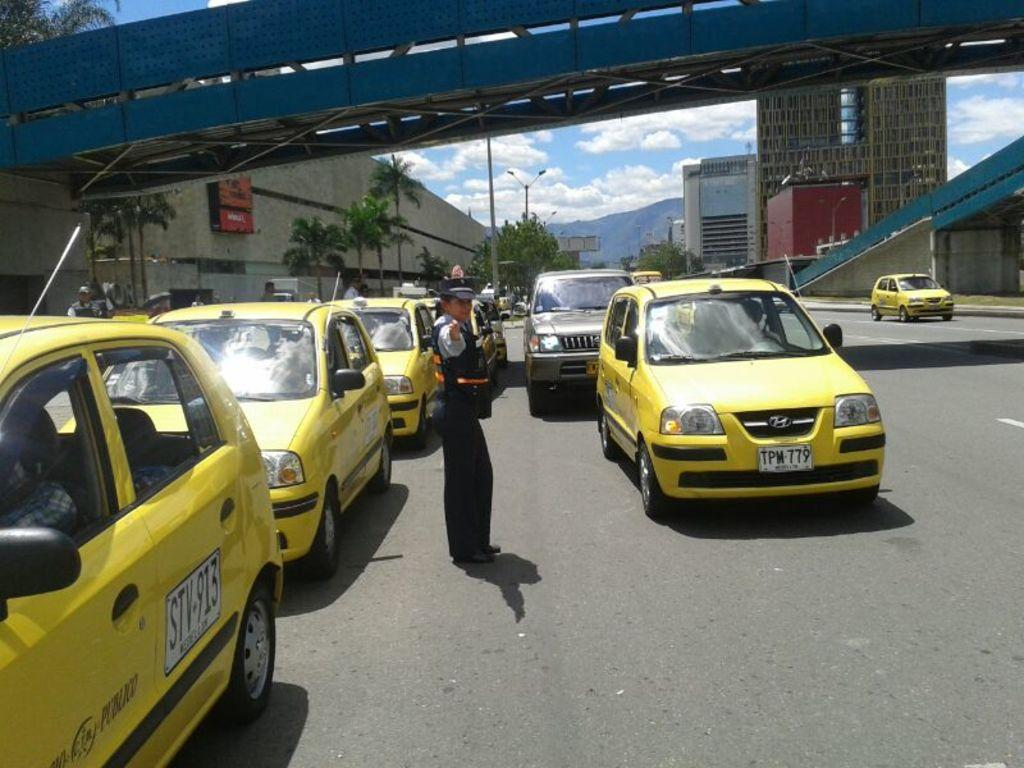<image>
Share a concise interpretation of the image provided. Various yellow cars on a road, one with a license plate TPM-779. 